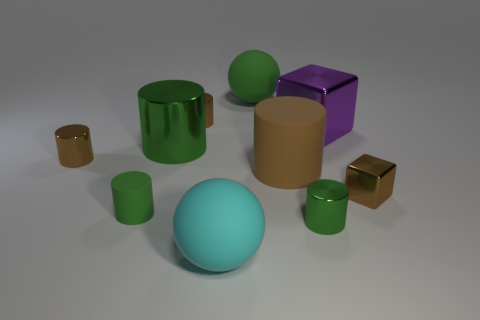Subtract all brown cylinders. How many were subtracted if there are1brown cylinders left? 2 Subtract all yellow spheres. How many brown cylinders are left? 3 Subtract all large matte cylinders. How many cylinders are left? 5 Subtract all yellow cylinders. Subtract all cyan spheres. How many cylinders are left? 6 Subtract all cylinders. How many objects are left? 4 Add 6 tiny gray rubber cubes. How many tiny gray rubber cubes exist? 6 Subtract 0 red blocks. How many objects are left? 10 Subtract all blocks. Subtract all cylinders. How many objects are left? 2 Add 3 matte things. How many matte things are left? 7 